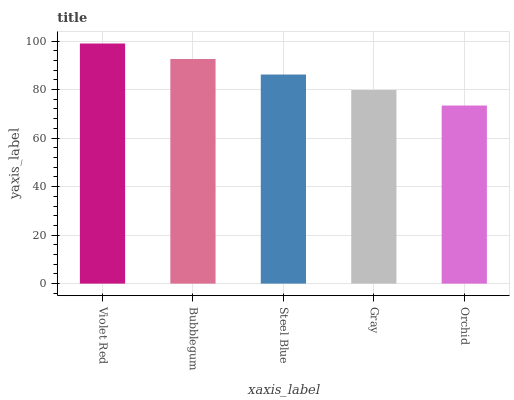Is Bubblegum the minimum?
Answer yes or no. No. Is Bubblegum the maximum?
Answer yes or no. No. Is Violet Red greater than Bubblegum?
Answer yes or no. Yes. Is Bubblegum less than Violet Red?
Answer yes or no. Yes. Is Bubblegum greater than Violet Red?
Answer yes or no. No. Is Violet Red less than Bubblegum?
Answer yes or no. No. Is Steel Blue the high median?
Answer yes or no. Yes. Is Steel Blue the low median?
Answer yes or no. Yes. Is Gray the high median?
Answer yes or no. No. Is Bubblegum the low median?
Answer yes or no. No. 